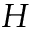<formula> <loc_0><loc_0><loc_500><loc_500>H</formula> 